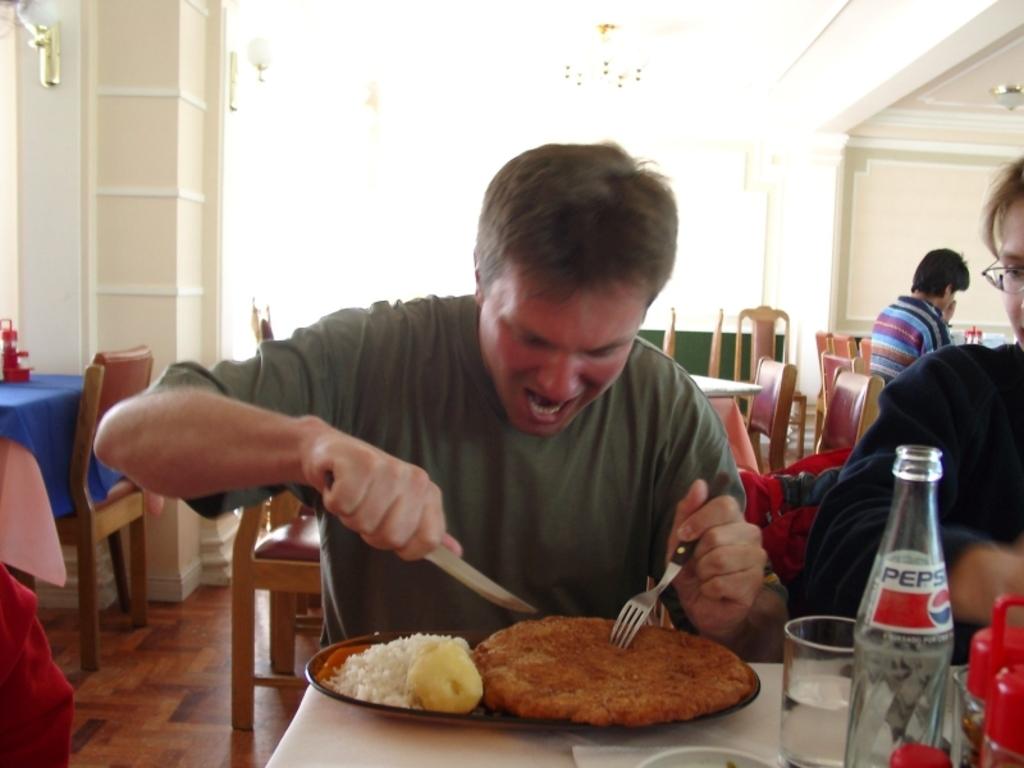Which soda is that on the right?
Your response must be concise. Pepsi. 